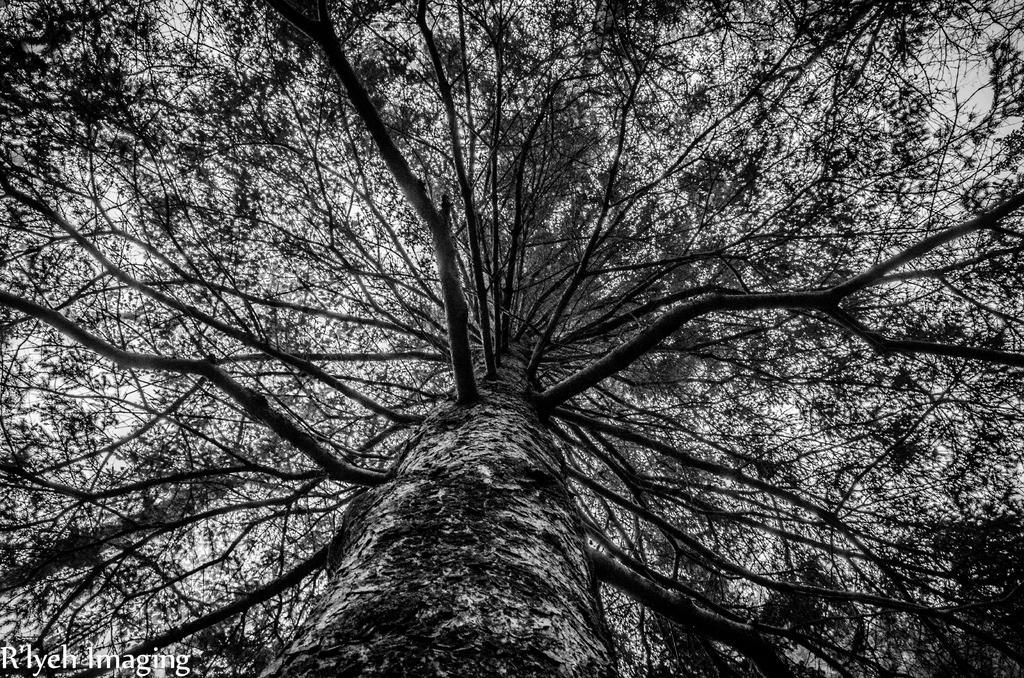Could you give a brief overview of what you see in this image? This is the picture of a tree. In this picture there is a long tree with many branches. At the top there is sky. In the bottom left there is a text. 